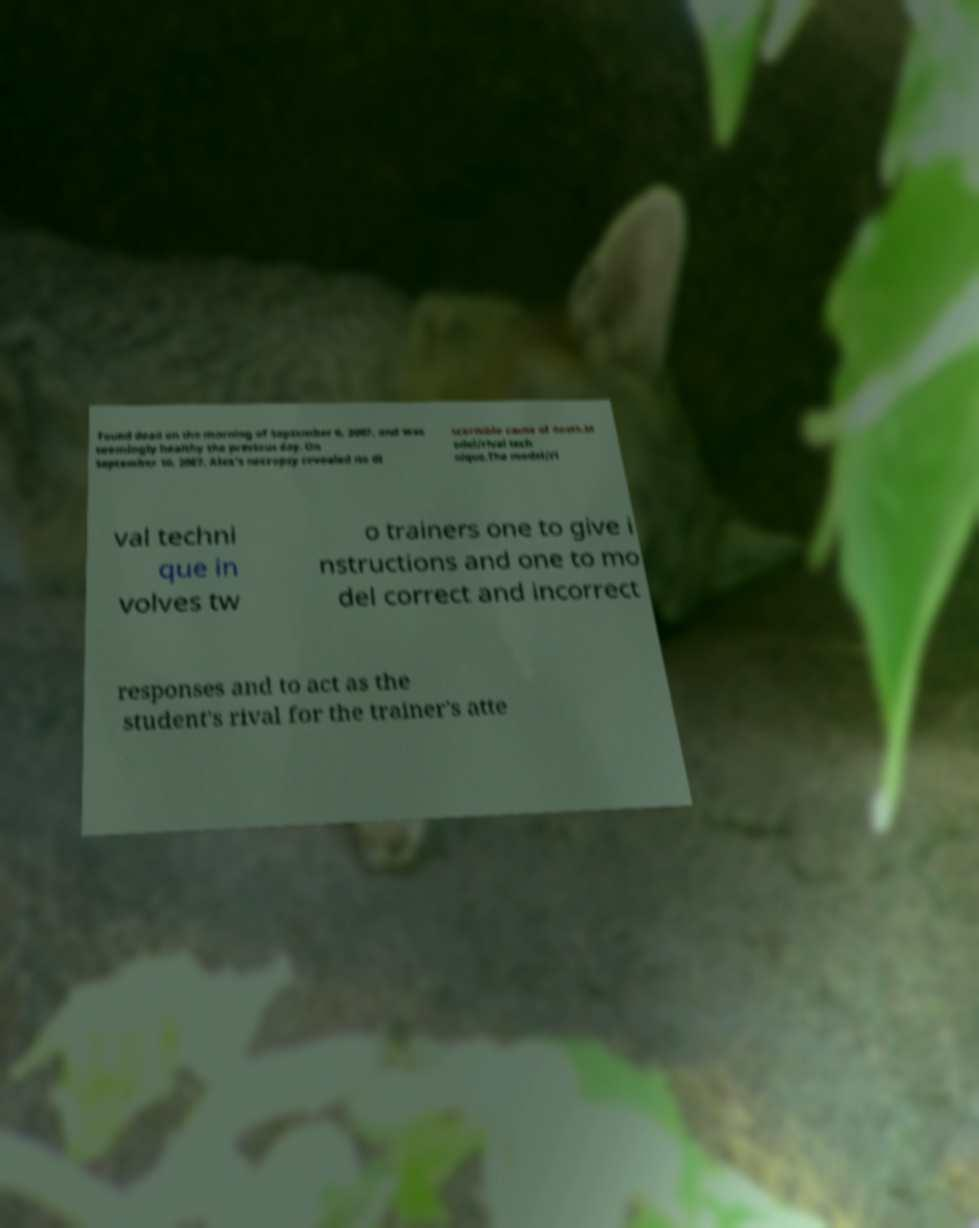For documentation purposes, I need the text within this image transcribed. Could you provide that? found dead on the morning of September 6, 2007, and was seemingly healthy the previous day. On September 10, 2007, Alex's necropsy revealed no di scernible cause of death.M odel/rival tech nique.The model/ri val techni que in volves tw o trainers one to give i nstructions and one to mo del correct and incorrect responses and to act as the student's rival for the trainer's atte 